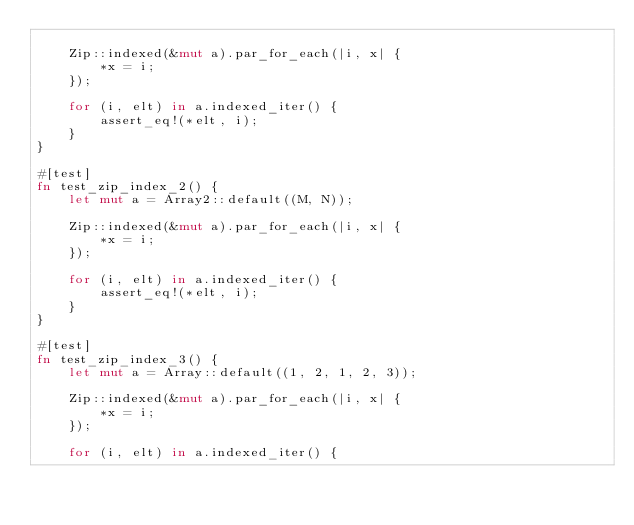Convert code to text. <code><loc_0><loc_0><loc_500><loc_500><_Rust_>
    Zip::indexed(&mut a).par_for_each(|i, x| {
        *x = i;
    });

    for (i, elt) in a.indexed_iter() {
        assert_eq!(*elt, i);
    }
}

#[test]
fn test_zip_index_2() {
    let mut a = Array2::default((M, N));

    Zip::indexed(&mut a).par_for_each(|i, x| {
        *x = i;
    });

    for (i, elt) in a.indexed_iter() {
        assert_eq!(*elt, i);
    }
}

#[test]
fn test_zip_index_3() {
    let mut a = Array::default((1, 2, 1, 2, 3));

    Zip::indexed(&mut a).par_for_each(|i, x| {
        *x = i;
    });

    for (i, elt) in a.indexed_iter() {</code> 